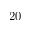Convert formula to latex. <formula><loc_0><loc_0><loc_500><loc_500>2 0</formula> 